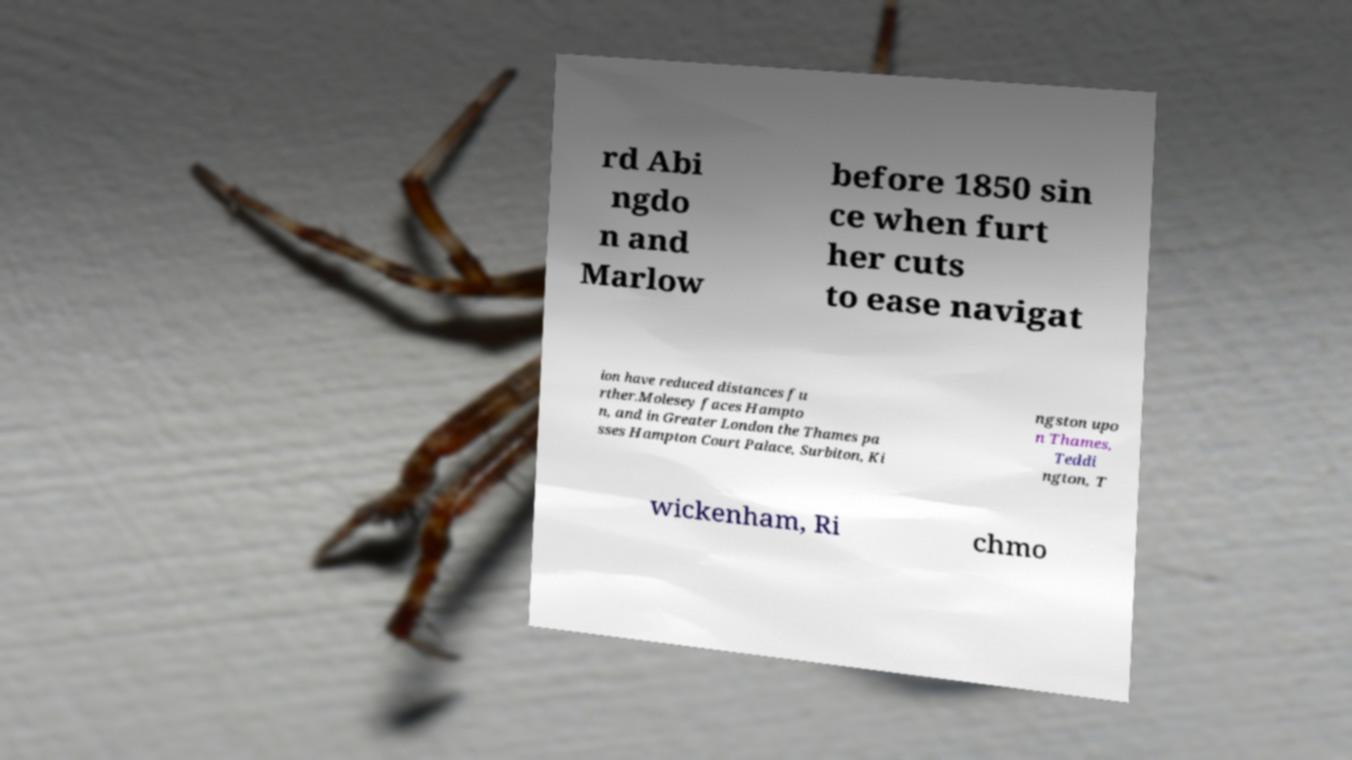What messages or text are displayed in this image? I need them in a readable, typed format. rd Abi ngdo n and Marlow before 1850 sin ce when furt her cuts to ease navigat ion have reduced distances fu rther.Molesey faces Hampto n, and in Greater London the Thames pa sses Hampton Court Palace, Surbiton, Ki ngston upo n Thames, Teddi ngton, T wickenham, Ri chmo 